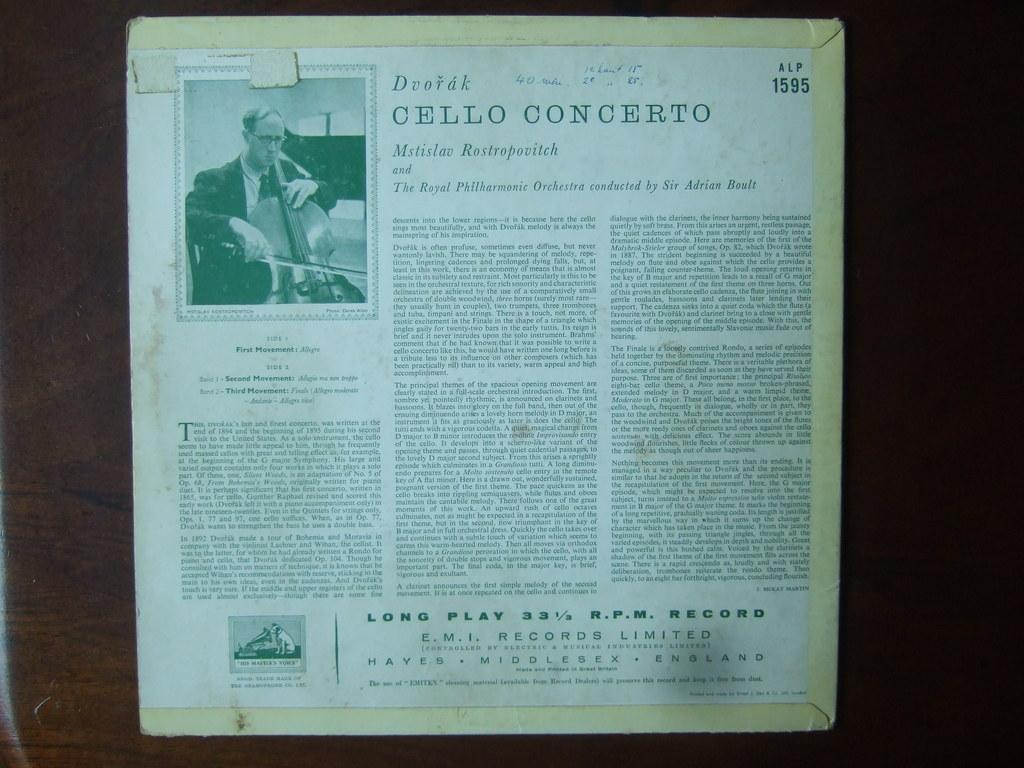What type of content is displayed in the image? There is an article of an editorial in the image. Where is the article located? The article is pasted on a wall. What can be found within the article? There is text in the article. Is there any visual element in the article? Yes, there is a picture of a person in the article. Can you tell me how many donkeys are depicted in the picture of the person in the article? There is no picture of a donkey in the image; it features a picture of a person. What type of nut is mentioned in the text of the article? There is no mention of a nut in the text of the article. 